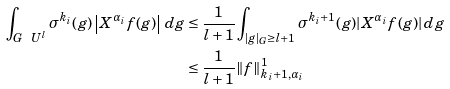<formula> <loc_0><loc_0><loc_500><loc_500>\int _ { G \ U ^ { l } } \sigma ^ { k _ { i } } ( g ) \left | X ^ { \alpha _ { i } } f ( g ) \right | \, d g & \leq \frac { 1 } { l + 1 } \int _ { | g | _ { G } \geq l + 1 } \sigma ^ { k _ { i } + 1 } ( g ) | X ^ { \alpha _ { i } } f ( g ) | \, d g \\ & \leq \frac { 1 } { l + 1 } \| f \| _ { k _ { i } + 1 , \alpha _ { i } } ^ { 1 }</formula> 